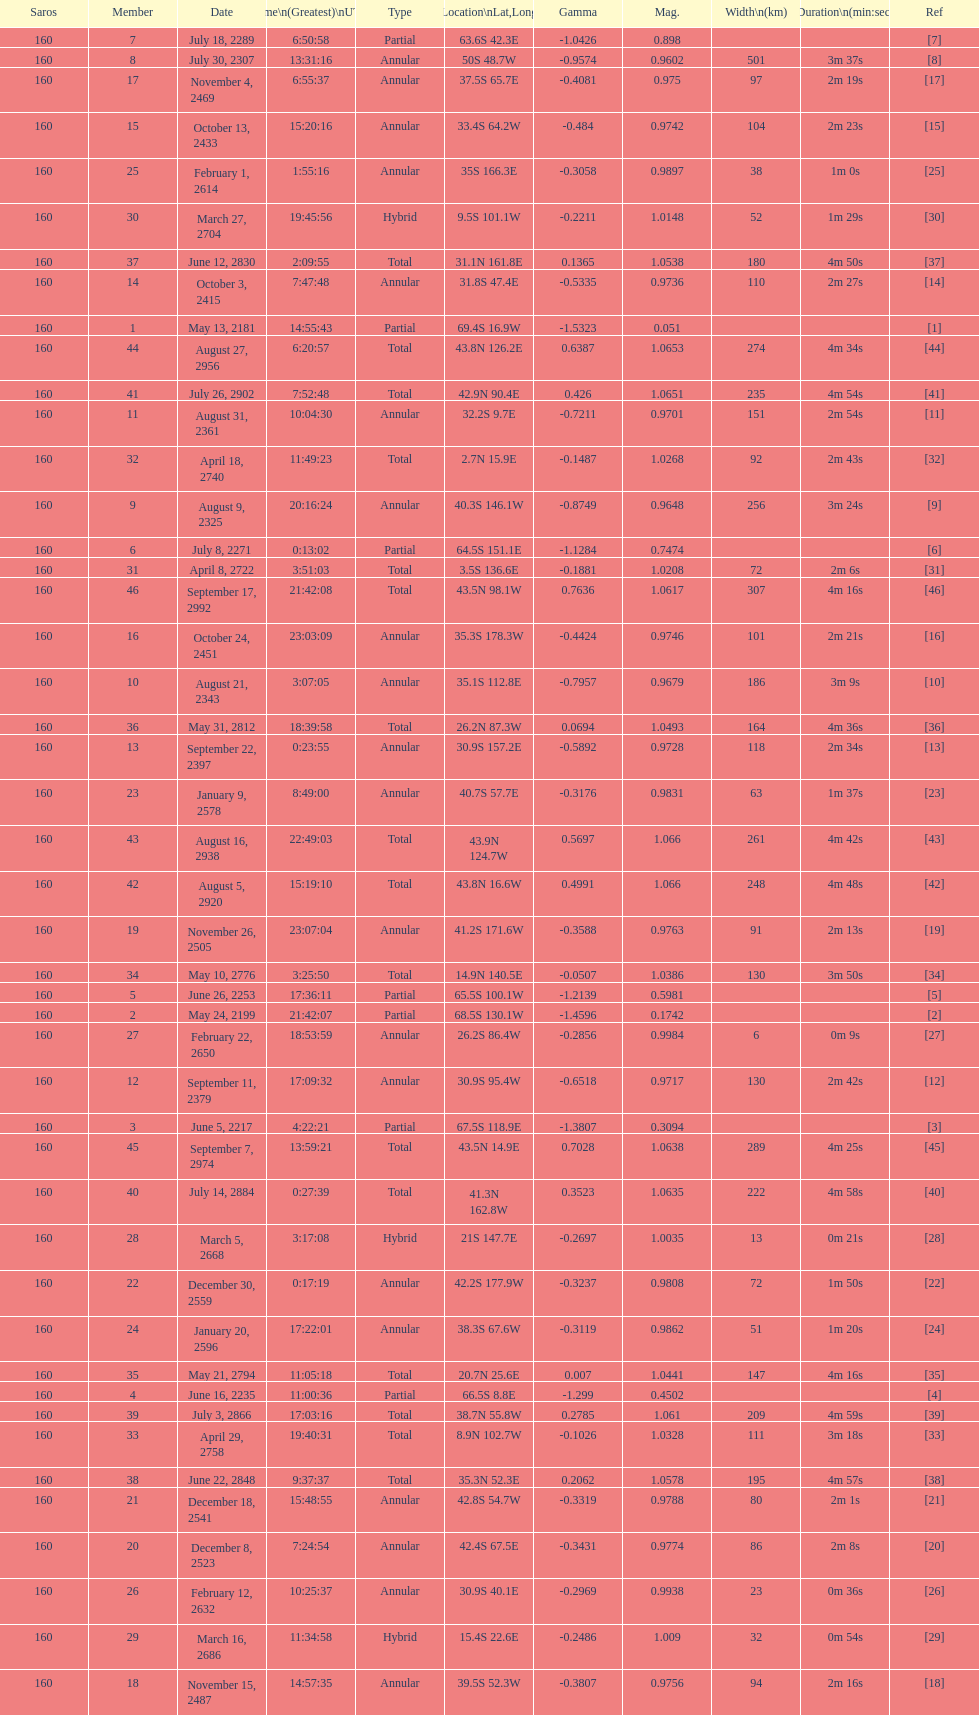How many partial members will occur before the first annular? 7. 